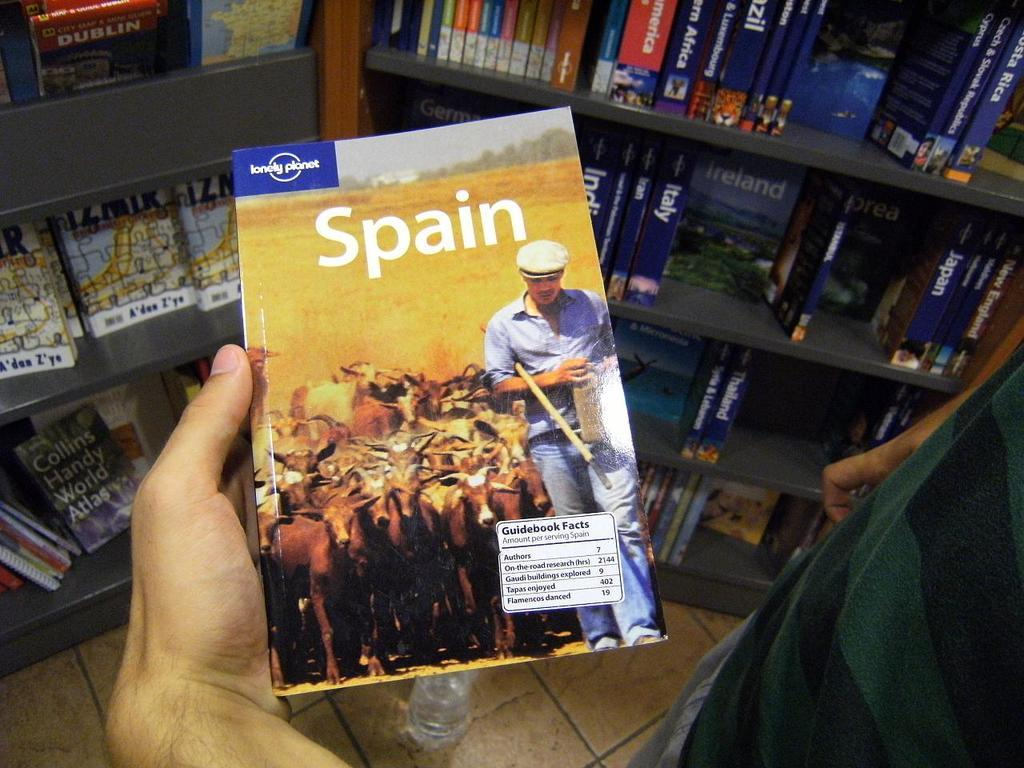<image>
Create a compact narrative representing the image presented. Spain book with a lonely planet logo on the top. 